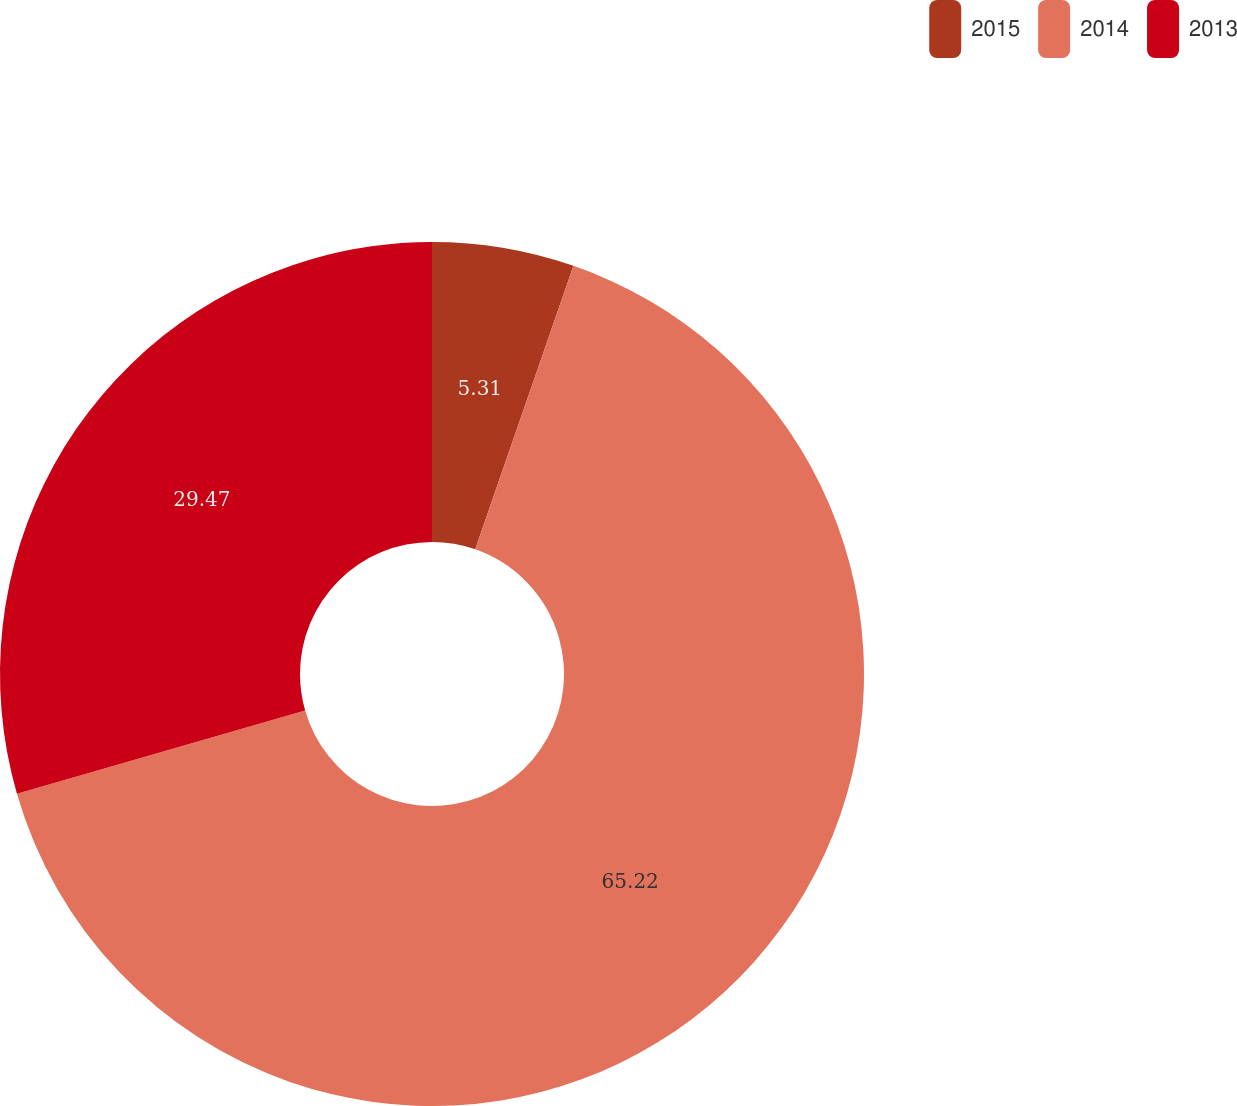<chart> <loc_0><loc_0><loc_500><loc_500><pie_chart><fcel>2015<fcel>2014<fcel>2013<nl><fcel>5.31%<fcel>65.22%<fcel>29.47%<nl></chart> 